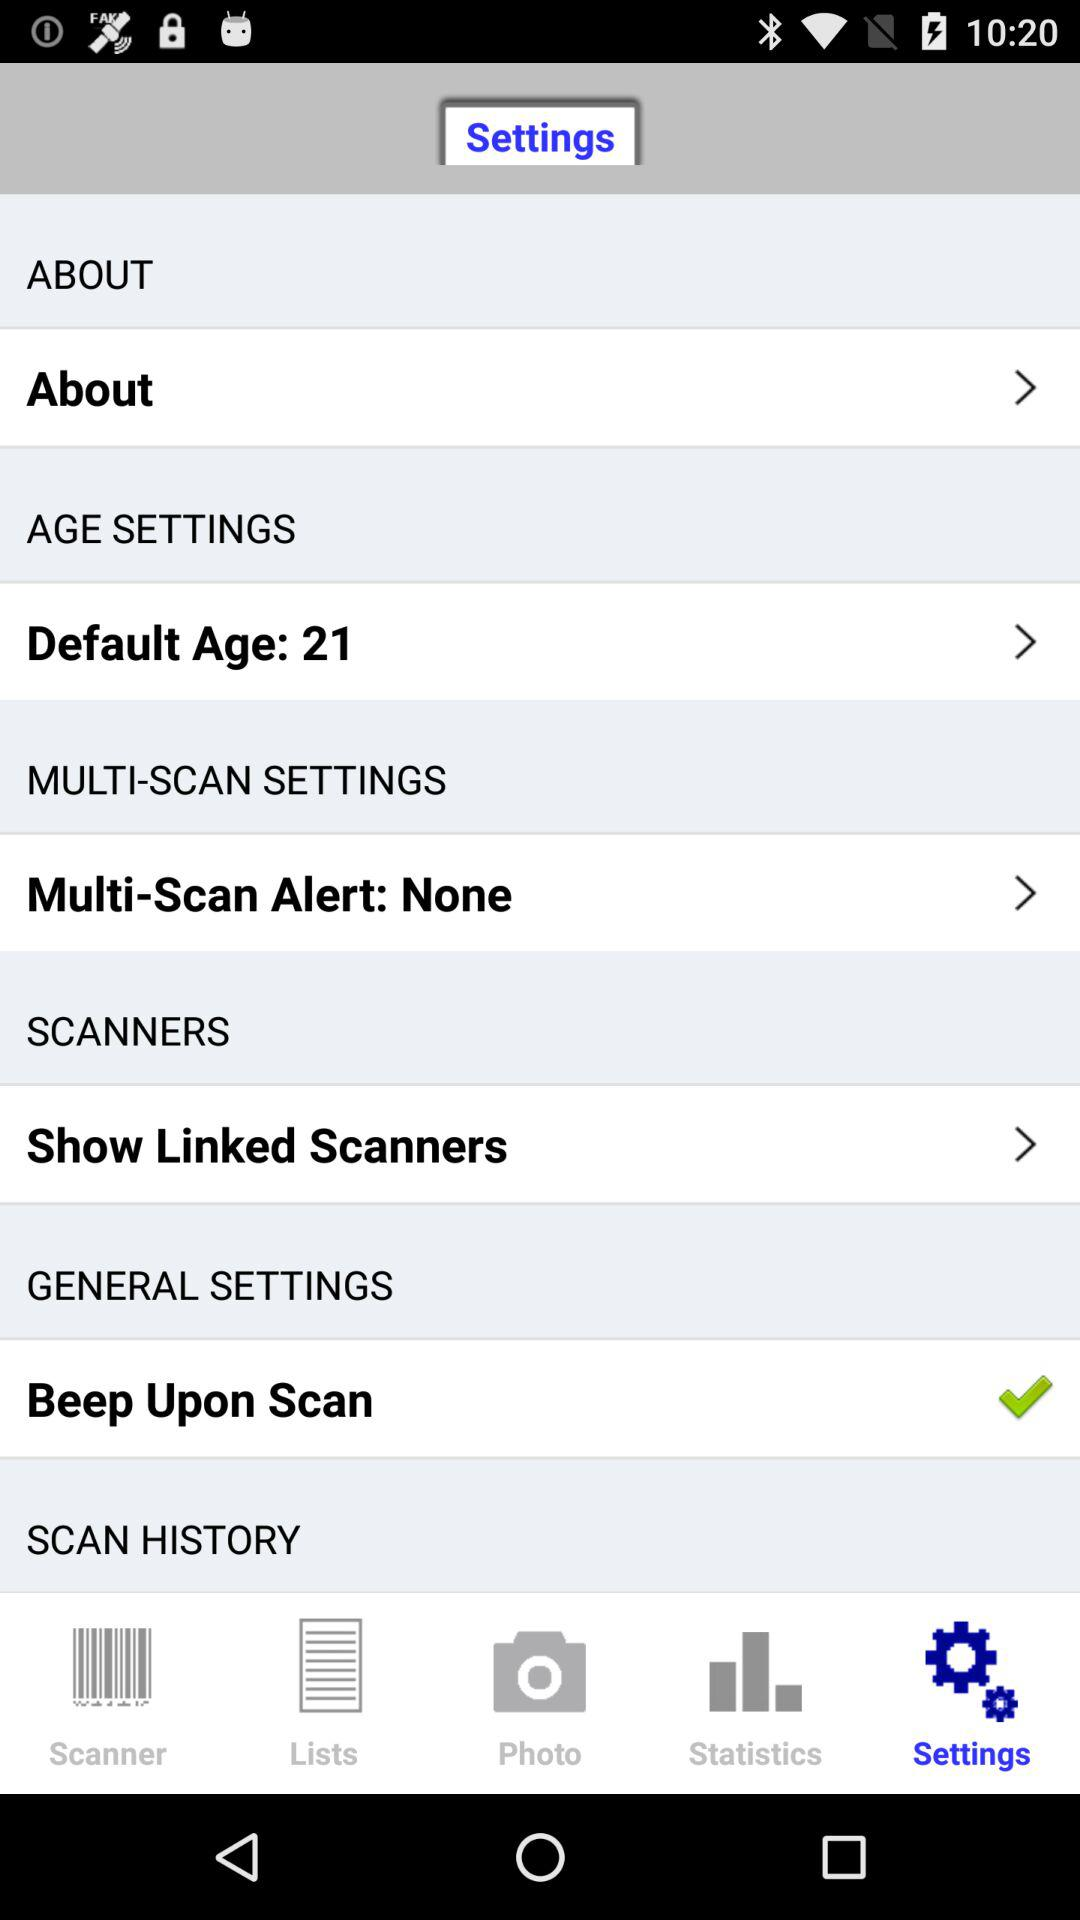Which tab is selected? The selected tab is "Settings". 